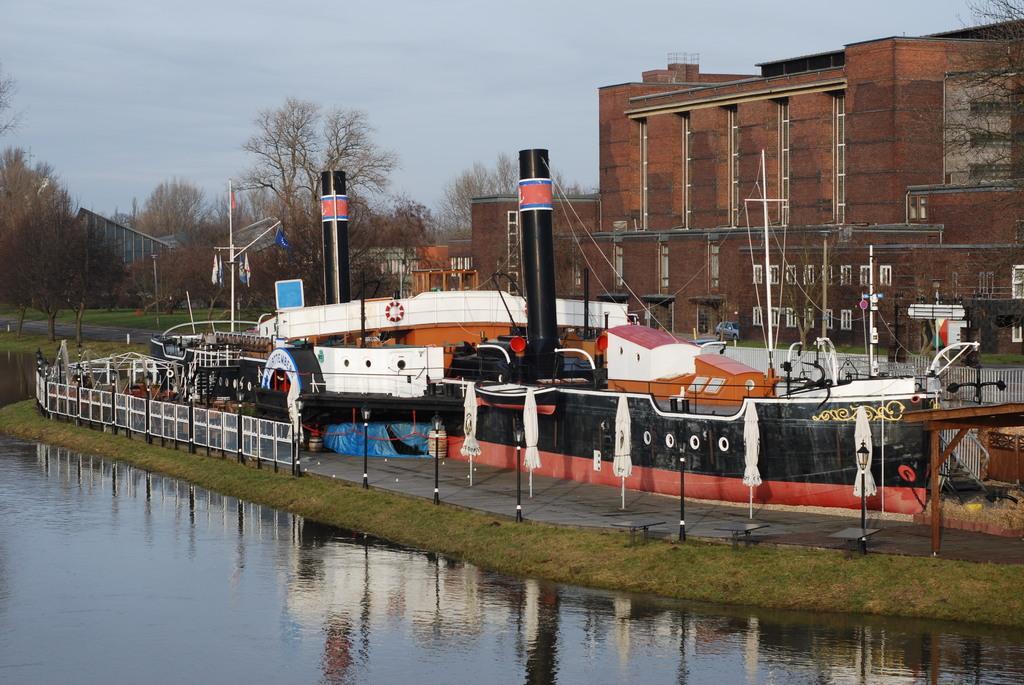Please provide a concise description of this image. In this image we can see light poles, umbrellas, railings, ship, trees, buildings, cloudy sky and things. Far there is a vehicle. 